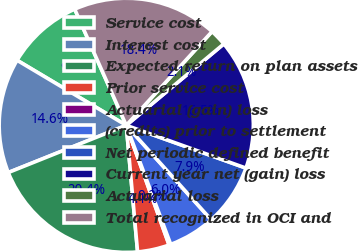Convert chart to OTSL. <chart><loc_0><loc_0><loc_500><loc_500><pie_chart><fcel>Service cost<fcel>Interest cost<fcel>Expected return on plan assets<fcel>Prior service cost<fcel>Actuarial (gain) loss<fcel>(credits) prior to settlement<fcel>Net periodic defined benefit<fcel>Current year net (gain) loss<fcel>Actuarial loss<fcel>Total recognized in OCI and<nl><fcel>9.8%<fcel>14.61%<fcel>20.36%<fcel>4.05%<fcel>0.22%<fcel>5.97%<fcel>7.88%<fcel>16.53%<fcel>2.14%<fcel>18.44%<nl></chart> 